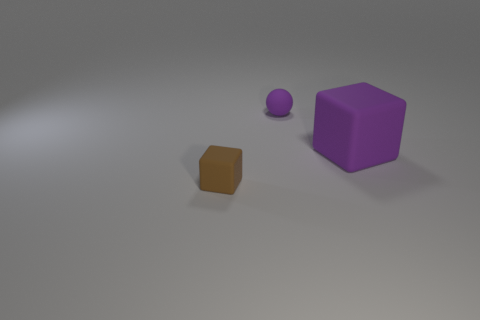What number of other things are the same color as the tiny rubber block?
Make the answer very short. 0. How big is the purple rubber thing that is on the right side of the purple rubber thing on the left side of the big cube?
Provide a succinct answer. Large. Do the cube on the left side of the large purple rubber object and the small purple object have the same material?
Ensure brevity in your answer.  Yes. There is a purple rubber object in front of the small purple matte object; what shape is it?
Make the answer very short. Cube. How many purple rubber things are the same size as the brown block?
Your answer should be compact. 1. What is the size of the purple ball?
Provide a short and direct response. Small. There is a big matte object; how many small purple spheres are behind it?
Provide a succinct answer. 1. What is the shape of the small purple thing that is made of the same material as the big thing?
Offer a terse response. Sphere. Are there fewer brown cubes that are behind the big purple object than purple things to the left of the purple rubber sphere?
Give a very brief answer. No. Is the number of big metal cubes greater than the number of big matte cubes?
Your answer should be very brief. No. 